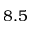<formula> <loc_0><loc_0><loc_500><loc_500>8 . 5</formula> 